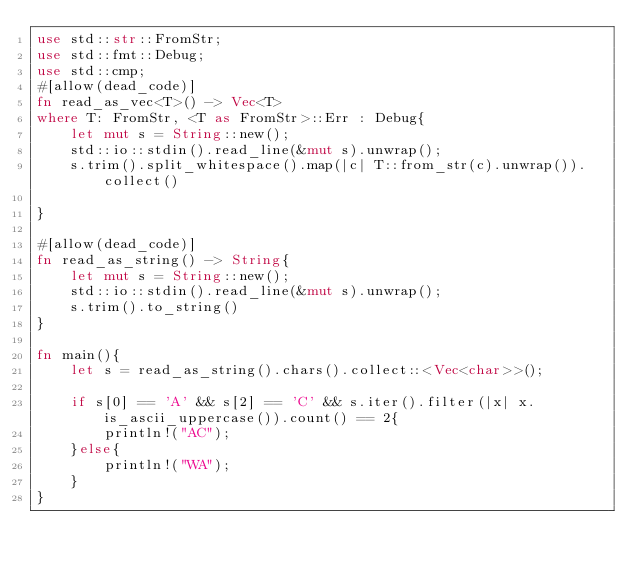<code> <loc_0><loc_0><loc_500><loc_500><_Rust_>use std::str::FromStr;
use std::fmt::Debug;
use std::cmp;
#[allow(dead_code)]
fn read_as_vec<T>() -> Vec<T>
where T: FromStr, <T as FromStr>::Err : Debug{
    let mut s = String::new();
    std::io::stdin().read_line(&mut s).unwrap();
    s.trim().split_whitespace().map(|c| T::from_str(c).unwrap()).collect()

}

#[allow(dead_code)]
fn read_as_string() -> String{
    let mut s = String::new();
    std::io::stdin().read_line(&mut s).unwrap();
    s.trim().to_string()
}

fn main(){
    let s = read_as_string().chars().collect::<Vec<char>>();

    if s[0] == 'A' && s[2] == 'C' && s.iter().filter(|x| x.is_ascii_uppercase()).count() == 2{
        println!("AC");
    }else{
        println!("WA");
    }
}
</code> 